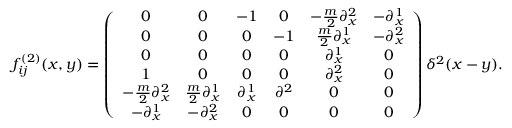Convert formula to latex. <formula><loc_0><loc_0><loc_500><loc_500>f _ { i j } ^ { ( 2 ) } ( x , y ) = \left ( \begin{array} { c c c c c c } { 0 } & { 0 } & { - 1 } & { 0 } & { { - \frac { m } { 2 } \partial _ { x } ^ { 2 } } } & { { - \partial _ { x } ^ { 1 } } } \\ { 0 } & { 0 } & { 0 } & { - 1 } & { { \frac { m } { 2 } \partial _ { x } ^ { 1 } } } & { { - \partial _ { x } ^ { 2 } } } \\ { 0 } & { 0 } & { 0 } & { 0 } & { { \partial _ { x } ^ { 1 } } } & { 0 } \\ { 1 } & { 0 } & { 0 } & { 0 } & { { \partial _ { x } ^ { 2 } } } & { 0 } \\ { { - \frac { m } { 2 } \partial _ { x } ^ { 2 } } } & { { \frac { m } { 2 } \partial _ { x } ^ { 1 } } } & { { \partial _ { x } ^ { 1 } } } & { { \partial ^ { 2 } } } & { 0 } & { 0 } \\ { { - \partial _ { x } ^ { 1 } } } & { { - \partial _ { x } ^ { 2 } } } & { 0 } & { 0 } & { 0 } & { 0 } \end{array} \right ) \delta ^ { 2 } ( x - y ) .</formula> 